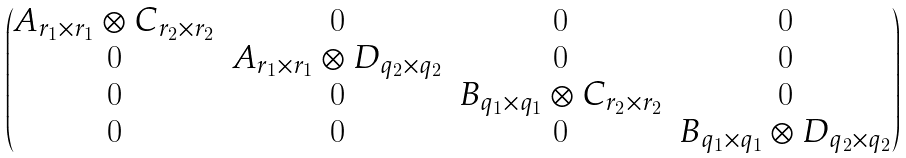Convert formula to latex. <formula><loc_0><loc_0><loc_500><loc_500>\begin{pmatrix} A _ { r _ { 1 } \times r _ { 1 } } \otimes C _ { r _ { 2 } \times r _ { 2 } } & 0 & 0 & 0 \\ 0 & A _ { r _ { 1 } \times r _ { 1 } } \otimes D _ { q _ { 2 } \times q _ { 2 } } & 0 & 0 \\ 0 & 0 & B _ { q _ { 1 } \times q _ { 1 } } \otimes C _ { r _ { 2 } \times r _ { 2 } } & 0 \\ 0 & 0 & 0 & B _ { q _ { 1 } \times q _ { 1 } } \otimes D _ { q _ { 2 } \times q _ { 2 } } \end{pmatrix}</formula> 